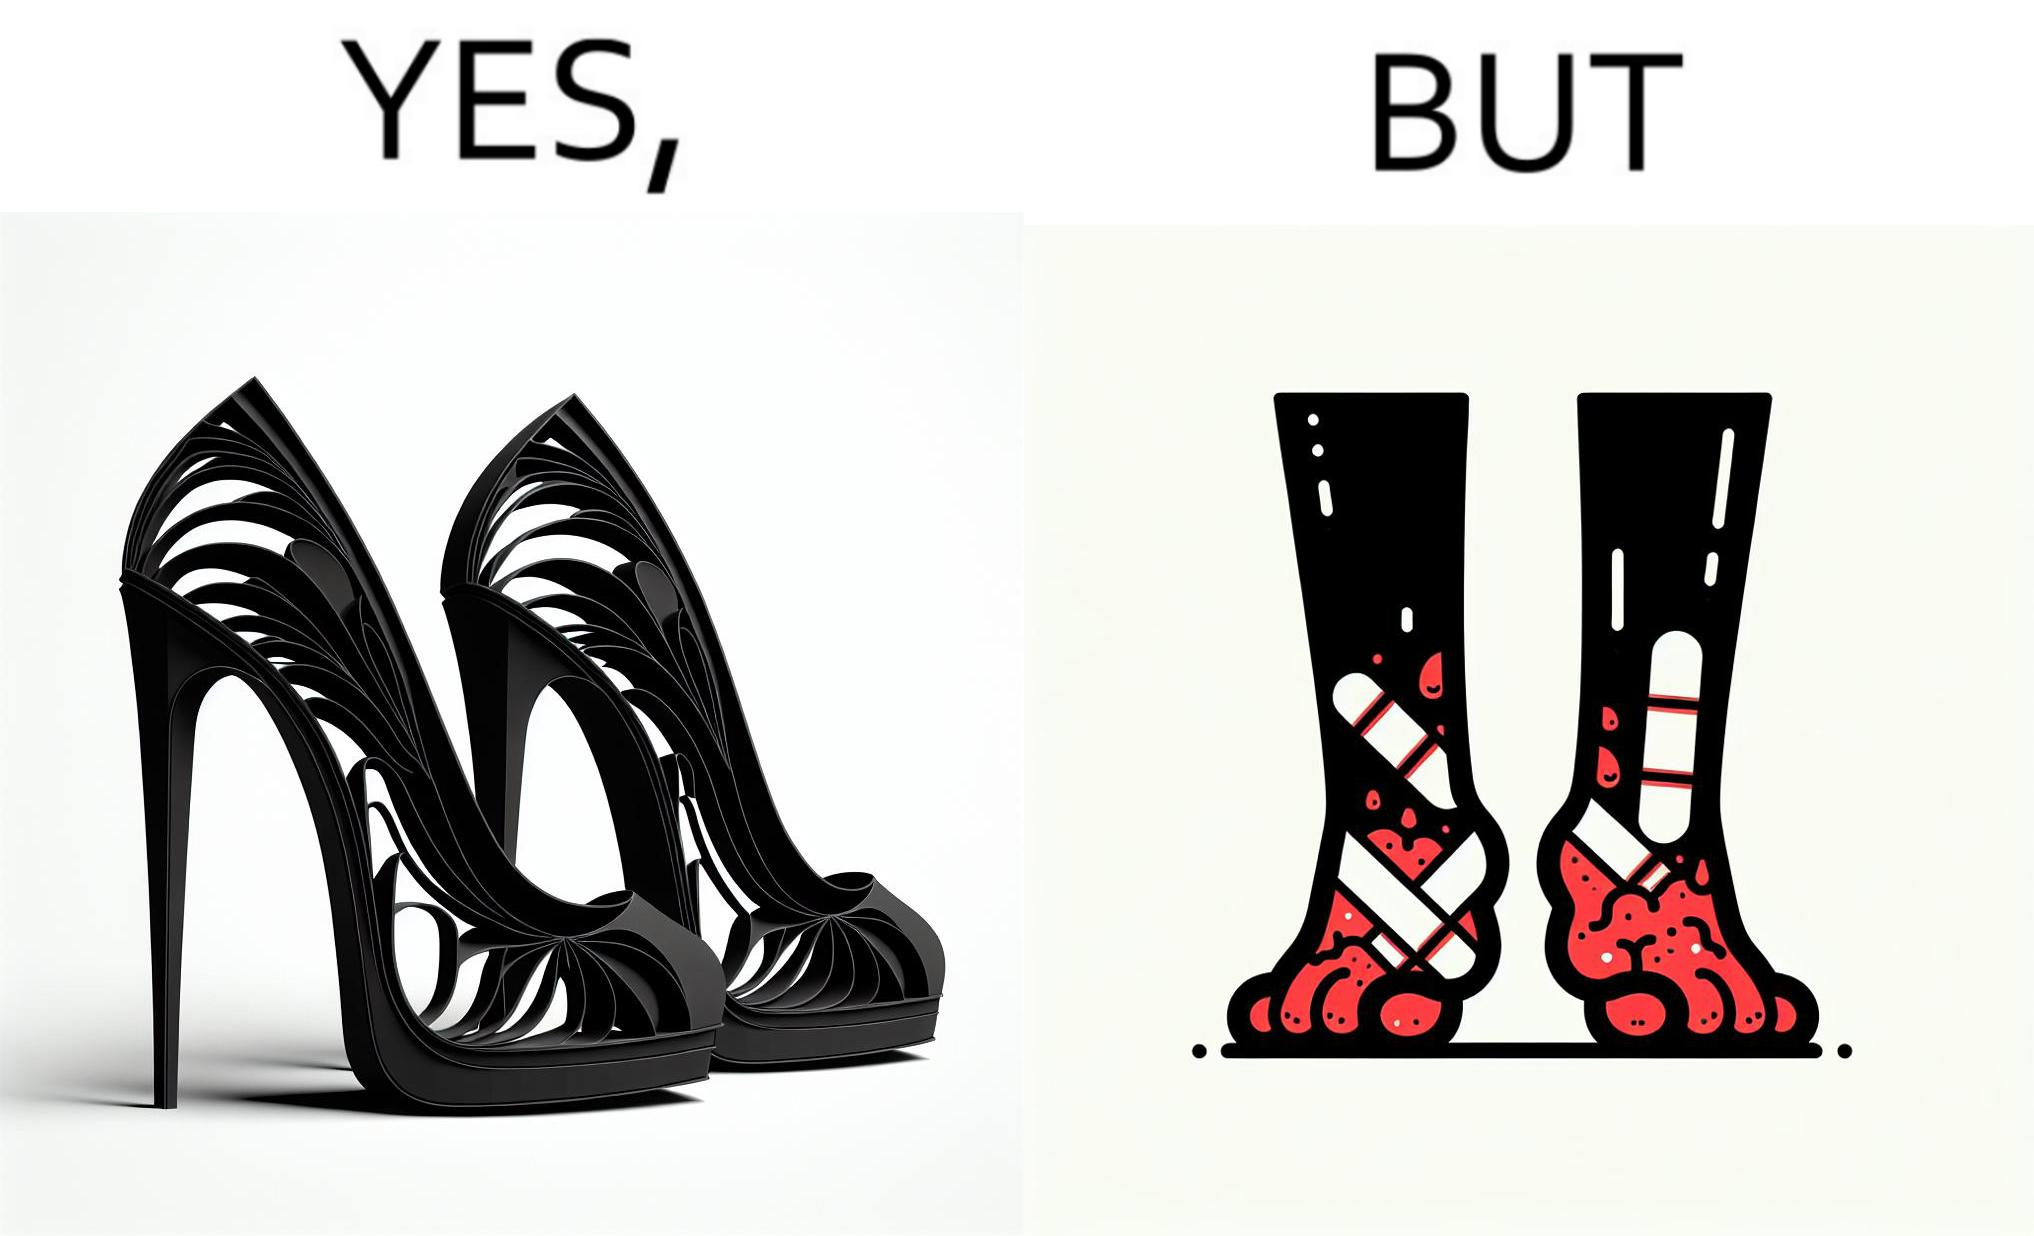Does this image contain satire or humor? Yes, this image is satirical. 